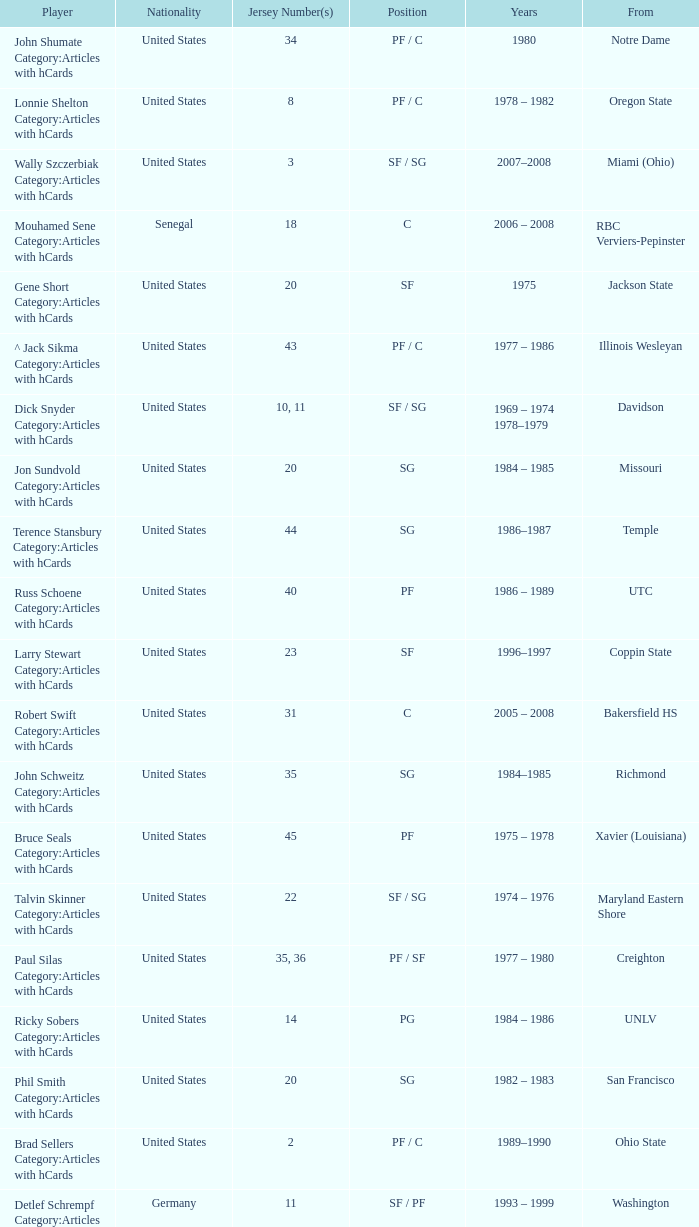What position does the player with jersey number 22 play? SF / SG. 